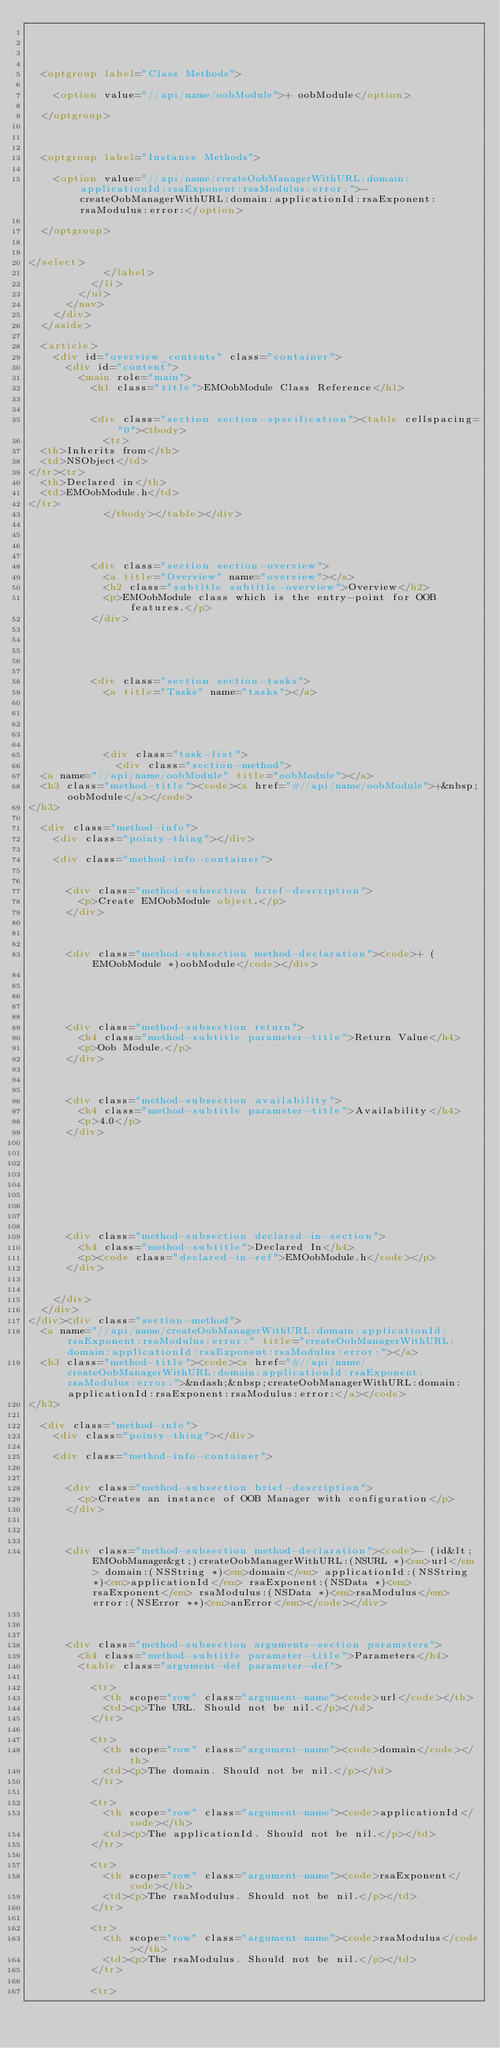<code> <loc_0><loc_0><loc_500><loc_500><_HTML_>	
	

	
	<optgroup label="Class Methods">
		
		<option value="//api/name/oobModule">+ oobModule</option>
		
	</optgroup>
	

	
	<optgroup label="Instance Methods">
		
		<option value="//api/name/createOobManagerWithURL:domain:applicationId:rsaExponent:rsaModulus:error:">- createOobManagerWithURL:domain:applicationId:rsaExponent:rsaModulus:error:</option>
		
	</optgroup>
	
	
</select>
						</label>
					</li>
				</ul>
			</nav>
		</div>
	</aside>

	<article>
		<div id="overview_contents" class="container">
			<div id="content">
				<main role="main">
					<h1 class="title">EMOobModule Class Reference</h1>

					
					<div class="section section-specification"><table cellspacing="0"><tbody>
						<tr>
	<th>Inherits from</th>
	<td>NSObject</td>
</tr><tr>
	<th>Declared in</th>
	<td>EMOobModule.h</td>
</tr>
						</tbody></table></div>
					

                    
					
					<div class="section section-overview">
						<a title="Overview" name="overview"></a>
						<h2 class="subtitle subtitle-overview">Overview</h2>
						<p>EMOobModule class which is the entry-point for OOB features.</p>
					</div>
					
					

					
					
					<div class="section section-tasks">
						<a title="Tasks" name="tasks"></a>
						

						
						

						<div class="task-list">
							<div class="section-method">
	<a name="//api/name/oobModule" title="oobModule"></a>
	<h3 class="method-title"><code><a href="#//api/name/oobModule">+&nbsp;oobModule</a></code>
</h3>

	<div class="method-info">
		<div class="pointy-thing"></div>

		<div class="method-info-container">
			
			
			<div class="method-subsection brief-description">
				<p>Create EMOobModule object.</p>
			</div>
			
		    

			<div class="method-subsection method-declaration"><code>+ (EMOobModule *)oobModule</code></div>

		    
			

			
			<div class="method-subsection return">
				<h4 class="method-subtitle parameter-title">Return Value</h4>
				<p>Oob Module.</p>
			</div>
			

			
			<div class="method-subsection availability">
				<h4 class="method-subtitle parameter-title">Availability</h4>
				<p>4.0</p>
			</div>
			

			

			

			

			
			<div class="method-subsection declared-in-section">
				<h4 class="method-subtitle">Declared In</h4>
				<p><code class="declared-in-ref">EMOobModule.h</code></p>
			</div>
			
			
		</div>
	</div>
</div><div class="section-method">
	<a name="//api/name/createOobManagerWithURL:domain:applicationId:rsaExponent:rsaModulus:error:" title="createOobManagerWithURL:domain:applicationId:rsaExponent:rsaModulus:error:"></a>
	<h3 class="method-title"><code><a href="#//api/name/createOobManagerWithURL:domain:applicationId:rsaExponent:rsaModulus:error:">&ndash;&nbsp;createOobManagerWithURL:domain:applicationId:rsaExponent:rsaModulus:error:</a></code>
</h3>

	<div class="method-info">
		<div class="pointy-thing"></div>

		<div class="method-info-container">
			
			
			<div class="method-subsection brief-description">
				<p>Creates an instance of OOB Manager with configuration</p>
			</div>
			
		    

			<div class="method-subsection method-declaration"><code>- (id&lt;EMOobManager&gt;)createOobManagerWithURL:(NSURL *)<em>url</em> domain:(NSString *)<em>domain</em> applicationId:(NSString *)<em>applicationId</em> rsaExponent:(NSData *)<em>rsaExponent</em> rsaModulus:(NSData *)<em>rsaModulus</em> error:(NSError **)<em>anError</em></code></div>

		    
			
			<div class="method-subsection arguments-section parameters">
				<h4 class="method-subtitle parameter-title">Parameters</h4>
				<table class="argument-def parameter-def">
				
					<tr>
						<th scope="row" class="argument-name"><code>url</code></th>
						<td><p>The URL. Should not be nil.</p></td>
					</tr>
				
					<tr>
						<th scope="row" class="argument-name"><code>domain</code></th>
						<td><p>The domain. Should not be nil.</p></td>
					</tr>
				
					<tr>
						<th scope="row" class="argument-name"><code>applicationId</code></th>
						<td><p>The applicationId. Should not be nil.</p></td>
					</tr>
				
					<tr>
						<th scope="row" class="argument-name"><code>rsaExponent</code></th>
						<td><p>The rsaModulus. Should not be nil.</p></td>
					</tr>
				
					<tr>
						<th scope="row" class="argument-name"><code>rsaModulus</code></th>
						<td><p>The rsaModulus. Should not be nil.</p></td>
					</tr>
				
					<tr></code> 